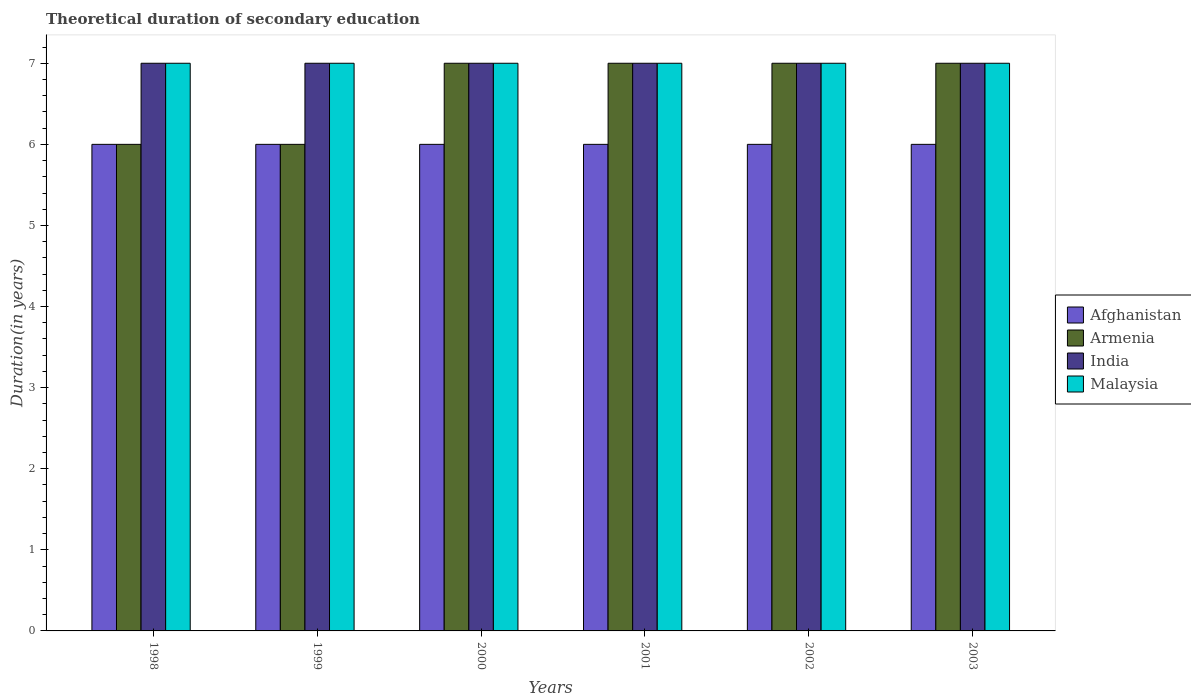How many different coloured bars are there?
Your answer should be compact. 4. How many bars are there on the 3rd tick from the left?
Keep it short and to the point. 4. What is the total theoretical duration of secondary education in Afghanistan in 2000?
Your answer should be very brief. 6. Across all years, what is the maximum total theoretical duration of secondary education in Afghanistan?
Your response must be concise. 6. Across all years, what is the minimum total theoretical duration of secondary education in Afghanistan?
Your response must be concise. 6. In which year was the total theoretical duration of secondary education in Armenia minimum?
Your answer should be compact. 1998. What is the total total theoretical duration of secondary education in Malaysia in the graph?
Ensure brevity in your answer.  42. What is the difference between the total theoretical duration of secondary education in Afghanistan in 2003 and the total theoretical duration of secondary education in Malaysia in 2002?
Your answer should be very brief. -1. What is the average total theoretical duration of secondary education in India per year?
Your response must be concise. 7. In how many years, is the total theoretical duration of secondary education in Afghanistan greater than 5.4 years?
Provide a short and direct response. 6. Is the difference between the total theoretical duration of secondary education in India in 1999 and 2001 greater than the difference between the total theoretical duration of secondary education in Malaysia in 1999 and 2001?
Offer a terse response. No. Is the sum of the total theoretical duration of secondary education in Malaysia in 1999 and 2001 greater than the maximum total theoretical duration of secondary education in Afghanistan across all years?
Give a very brief answer. Yes. What does the 2nd bar from the left in 1999 represents?
Provide a succinct answer. Armenia. What does the 3rd bar from the right in 1998 represents?
Keep it short and to the point. Armenia. Is it the case that in every year, the sum of the total theoretical duration of secondary education in Afghanistan and total theoretical duration of secondary education in Malaysia is greater than the total theoretical duration of secondary education in India?
Provide a short and direct response. Yes. Are all the bars in the graph horizontal?
Your answer should be compact. No. What is the difference between two consecutive major ticks on the Y-axis?
Offer a very short reply. 1. Are the values on the major ticks of Y-axis written in scientific E-notation?
Your answer should be compact. No. Does the graph contain grids?
Offer a very short reply. No. What is the title of the graph?
Your answer should be compact. Theoretical duration of secondary education. What is the label or title of the X-axis?
Make the answer very short. Years. What is the label or title of the Y-axis?
Provide a succinct answer. Duration(in years). What is the Duration(in years) in Afghanistan in 1998?
Offer a very short reply. 6. What is the Duration(in years) of Malaysia in 1998?
Keep it short and to the point. 7. What is the Duration(in years) of Afghanistan in 1999?
Your response must be concise. 6. What is the Duration(in years) of Armenia in 1999?
Give a very brief answer. 6. What is the Duration(in years) in India in 1999?
Provide a succinct answer. 7. What is the Duration(in years) in Afghanistan in 2000?
Keep it short and to the point. 6. What is the Duration(in years) in Armenia in 2000?
Provide a succinct answer. 7. What is the Duration(in years) in Malaysia in 2001?
Offer a terse response. 7. What is the Duration(in years) of Malaysia in 2002?
Ensure brevity in your answer.  7. What is the Duration(in years) of Afghanistan in 2003?
Give a very brief answer. 6. What is the Duration(in years) in India in 2003?
Provide a succinct answer. 7. What is the Duration(in years) of Malaysia in 2003?
Provide a succinct answer. 7. Across all years, what is the maximum Duration(in years) of Armenia?
Your answer should be compact. 7. Across all years, what is the minimum Duration(in years) in Armenia?
Your answer should be compact. 6. Across all years, what is the minimum Duration(in years) in Malaysia?
Ensure brevity in your answer.  7. What is the total Duration(in years) in India in the graph?
Your answer should be compact. 42. What is the difference between the Duration(in years) in Afghanistan in 1998 and that in 1999?
Make the answer very short. 0. What is the difference between the Duration(in years) in Armenia in 1998 and that in 1999?
Your answer should be compact. 0. What is the difference between the Duration(in years) in India in 1998 and that in 1999?
Offer a terse response. 0. What is the difference between the Duration(in years) in Malaysia in 1998 and that in 2000?
Ensure brevity in your answer.  0. What is the difference between the Duration(in years) of India in 1998 and that in 2001?
Your response must be concise. 0. What is the difference between the Duration(in years) of Malaysia in 1998 and that in 2001?
Keep it short and to the point. 0. What is the difference between the Duration(in years) in Afghanistan in 1998 and that in 2002?
Your answer should be very brief. 0. What is the difference between the Duration(in years) of Malaysia in 1998 and that in 2002?
Your response must be concise. 0. What is the difference between the Duration(in years) in Armenia in 1999 and that in 2000?
Provide a short and direct response. -1. What is the difference between the Duration(in years) of Malaysia in 1999 and that in 2000?
Your answer should be very brief. 0. What is the difference between the Duration(in years) in Afghanistan in 1999 and that in 2001?
Your answer should be very brief. 0. What is the difference between the Duration(in years) in Armenia in 1999 and that in 2001?
Make the answer very short. -1. What is the difference between the Duration(in years) of India in 1999 and that in 2002?
Your response must be concise. 0. What is the difference between the Duration(in years) in Afghanistan in 1999 and that in 2003?
Ensure brevity in your answer.  0. What is the difference between the Duration(in years) in India in 1999 and that in 2003?
Your response must be concise. 0. What is the difference between the Duration(in years) of Afghanistan in 2000 and that in 2001?
Your answer should be very brief. 0. What is the difference between the Duration(in years) of Armenia in 2000 and that in 2001?
Keep it short and to the point. 0. What is the difference between the Duration(in years) of Malaysia in 2000 and that in 2001?
Provide a short and direct response. 0. What is the difference between the Duration(in years) of Armenia in 2000 and that in 2003?
Your answer should be compact. 0. What is the difference between the Duration(in years) of India in 2000 and that in 2003?
Offer a terse response. 0. What is the difference between the Duration(in years) of Malaysia in 2000 and that in 2003?
Your answer should be very brief. 0. What is the difference between the Duration(in years) in Afghanistan in 2001 and that in 2002?
Offer a terse response. 0. What is the difference between the Duration(in years) of Armenia in 2001 and that in 2002?
Ensure brevity in your answer.  0. What is the difference between the Duration(in years) of India in 2001 and that in 2002?
Offer a very short reply. 0. What is the difference between the Duration(in years) in India in 2001 and that in 2003?
Make the answer very short. 0. What is the difference between the Duration(in years) in Armenia in 2002 and that in 2003?
Keep it short and to the point. 0. What is the difference between the Duration(in years) in India in 2002 and that in 2003?
Ensure brevity in your answer.  0. What is the difference between the Duration(in years) of Afghanistan in 1998 and the Duration(in years) of Armenia in 1999?
Offer a terse response. 0. What is the difference between the Duration(in years) of Afghanistan in 1998 and the Duration(in years) of Malaysia in 1999?
Ensure brevity in your answer.  -1. What is the difference between the Duration(in years) in India in 1998 and the Duration(in years) in Malaysia in 1999?
Offer a terse response. 0. What is the difference between the Duration(in years) of Afghanistan in 1998 and the Duration(in years) of Armenia in 2000?
Your answer should be compact. -1. What is the difference between the Duration(in years) in Afghanistan in 1998 and the Duration(in years) in India in 2000?
Give a very brief answer. -1. What is the difference between the Duration(in years) of Afghanistan in 1998 and the Duration(in years) of Armenia in 2001?
Your answer should be very brief. -1. What is the difference between the Duration(in years) in Afghanistan in 1998 and the Duration(in years) in Malaysia in 2001?
Your answer should be very brief. -1. What is the difference between the Duration(in years) of Armenia in 1998 and the Duration(in years) of India in 2001?
Offer a terse response. -1. What is the difference between the Duration(in years) in Armenia in 1998 and the Duration(in years) in Malaysia in 2001?
Keep it short and to the point. -1. What is the difference between the Duration(in years) of India in 1998 and the Duration(in years) of Malaysia in 2001?
Provide a short and direct response. 0. What is the difference between the Duration(in years) of Afghanistan in 1998 and the Duration(in years) of Armenia in 2002?
Your answer should be very brief. -1. What is the difference between the Duration(in years) in Afghanistan in 1998 and the Duration(in years) in India in 2002?
Your response must be concise. -1. What is the difference between the Duration(in years) of Afghanistan in 1998 and the Duration(in years) of Malaysia in 2002?
Give a very brief answer. -1. What is the difference between the Duration(in years) of Armenia in 1998 and the Duration(in years) of Malaysia in 2002?
Your response must be concise. -1. What is the difference between the Duration(in years) in Afghanistan in 1998 and the Duration(in years) in Armenia in 2003?
Offer a terse response. -1. What is the difference between the Duration(in years) in Armenia in 1998 and the Duration(in years) in India in 2003?
Your answer should be very brief. -1. What is the difference between the Duration(in years) of Afghanistan in 1999 and the Duration(in years) of Armenia in 2000?
Ensure brevity in your answer.  -1. What is the difference between the Duration(in years) in Afghanistan in 1999 and the Duration(in years) in Malaysia in 2000?
Provide a succinct answer. -1. What is the difference between the Duration(in years) of Afghanistan in 1999 and the Duration(in years) of India in 2001?
Make the answer very short. -1. What is the difference between the Duration(in years) in Afghanistan in 1999 and the Duration(in years) in Malaysia in 2001?
Your answer should be very brief. -1. What is the difference between the Duration(in years) of Armenia in 1999 and the Duration(in years) of Malaysia in 2001?
Provide a succinct answer. -1. What is the difference between the Duration(in years) of Afghanistan in 1999 and the Duration(in years) of Armenia in 2002?
Your answer should be compact. -1. What is the difference between the Duration(in years) in India in 1999 and the Duration(in years) in Malaysia in 2002?
Provide a succinct answer. 0. What is the difference between the Duration(in years) of Armenia in 1999 and the Duration(in years) of India in 2003?
Make the answer very short. -1. What is the difference between the Duration(in years) in Afghanistan in 2000 and the Duration(in years) in Armenia in 2001?
Your response must be concise. -1. What is the difference between the Duration(in years) of Afghanistan in 2000 and the Duration(in years) of India in 2001?
Provide a short and direct response. -1. What is the difference between the Duration(in years) of Armenia in 2000 and the Duration(in years) of Malaysia in 2001?
Provide a short and direct response. 0. What is the difference between the Duration(in years) of Afghanistan in 2000 and the Duration(in years) of Armenia in 2002?
Ensure brevity in your answer.  -1. What is the difference between the Duration(in years) of Afghanistan in 2000 and the Duration(in years) of India in 2002?
Give a very brief answer. -1. What is the difference between the Duration(in years) in Afghanistan in 2000 and the Duration(in years) in Malaysia in 2002?
Offer a terse response. -1. What is the difference between the Duration(in years) in Armenia in 2000 and the Duration(in years) in India in 2002?
Your response must be concise. 0. What is the difference between the Duration(in years) in Armenia in 2000 and the Duration(in years) in Malaysia in 2002?
Your response must be concise. 0. What is the difference between the Duration(in years) of Afghanistan in 2000 and the Duration(in years) of Armenia in 2003?
Your answer should be very brief. -1. What is the difference between the Duration(in years) in Afghanistan in 2000 and the Duration(in years) in India in 2003?
Your answer should be compact. -1. What is the difference between the Duration(in years) of India in 2000 and the Duration(in years) of Malaysia in 2003?
Make the answer very short. 0. What is the difference between the Duration(in years) in Afghanistan in 2001 and the Duration(in years) in Armenia in 2002?
Ensure brevity in your answer.  -1. What is the difference between the Duration(in years) of Afghanistan in 2001 and the Duration(in years) of India in 2002?
Give a very brief answer. -1. What is the difference between the Duration(in years) of Afghanistan in 2001 and the Duration(in years) of Malaysia in 2002?
Your answer should be very brief. -1. What is the difference between the Duration(in years) of Armenia in 2001 and the Duration(in years) of Malaysia in 2002?
Provide a short and direct response. 0. What is the difference between the Duration(in years) in India in 2001 and the Duration(in years) in Malaysia in 2002?
Your answer should be compact. 0. What is the difference between the Duration(in years) in Afghanistan in 2001 and the Duration(in years) in India in 2003?
Your answer should be very brief. -1. What is the difference between the Duration(in years) in Afghanistan in 2001 and the Duration(in years) in Malaysia in 2003?
Your answer should be compact. -1. What is the difference between the Duration(in years) in Armenia in 2001 and the Duration(in years) in India in 2003?
Your response must be concise. 0. What is the difference between the Duration(in years) in Armenia in 2001 and the Duration(in years) in Malaysia in 2003?
Give a very brief answer. 0. What is the difference between the Duration(in years) in Armenia in 2002 and the Duration(in years) in Malaysia in 2003?
Make the answer very short. 0. What is the difference between the Duration(in years) of India in 2002 and the Duration(in years) of Malaysia in 2003?
Keep it short and to the point. 0. What is the average Duration(in years) in Afghanistan per year?
Keep it short and to the point. 6. What is the average Duration(in years) in Armenia per year?
Your answer should be compact. 6.67. What is the average Duration(in years) of India per year?
Offer a very short reply. 7. What is the average Duration(in years) of Malaysia per year?
Offer a terse response. 7. In the year 1998, what is the difference between the Duration(in years) in Afghanistan and Duration(in years) in Armenia?
Offer a terse response. 0. In the year 1998, what is the difference between the Duration(in years) of Afghanistan and Duration(in years) of India?
Your answer should be compact. -1. In the year 1998, what is the difference between the Duration(in years) of Armenia and Duration(in years) of India?
Give a very brief answer. -1. In the year 1998, what is the difference between the Duration(in years) of India and Duration(in years) of Malaysia?
Keep it short and to the point. 0. In the year 1999, what is the difference between the Duration(in years) of Afghanistan and Duration(in years) of India?
Offer a very short reply. -1. In the year 1999, what is the difference between the Duration(in years) in Armenia and Duration(in years) in India?
Give a very brief answer. -1. In the year 1999, what is the difference between the Duration(in years) of Armenia and Duration(in years) of Malaysia?
Keep it short and to the point. -1. In the year 2000, what is the difference between the Duration(in years) of Afghanistan and Duration(in years) of Malaysia?
Make the answer very short. -1. In the year 2000, what is the difference between the Duration(in years) of Armenia and Duration(in years) of Malaysia?
Provide a succinct answer. 0. In the year 2000, what is the difference between the Duration(in years) of India and Duration(in years) of Malaysia?
Give a very brief answer. 0. In the year 2001, what is the difference between the Duration(in years) of Afghanistan and Duration(in years) of India?
Your answer should be very brief. -1. In the year 2001, what is the difference between the Duration(in years) in Afghanistan and Duration(in years) in Malaysia?
Provide a succinct answer. -1. In the year 2001, what is the difference between the Duration(in years) in Armenia and Duration(in years) in Malaysia?
Your answer should be compact. 0. In the year 2002, what is the difference between the Duration(in years) of Afghanistan and Duration(in years) of Armenia?
Ensure brevity in your answer.  -1. In the year 2002, what is the difference between the Duration(in years) in Armenia and Duration(in years) in Malaysia?
Give a very brief answer. 0. In the year 2003, what is the difference between the Duration(in years) of Afghanistan and Duration(in years) of Armenia?
Give a very brief answer. -1. In the year 2003, what is the difference between the Duration(in years) in Afghanistan and Duration(in years) in India?
Keep it short and to the point. -1. In the year 2003, what is the difference between the Duration(in years) in Armenia and Duration(in years) in Malaysia?
Keep it short and to the point. 0. In the year 2003, what is the difference between the Duration(in years) of India and Duration(in years) of Malaysia?
Your response must be concise. 0. What is the ratio of the Duration(in years) in Armenia in 1998 to that in 1999?
Your answer should be compact. 1. What is the ratio of the Duration(in years) of India in 1998 to that in 1999?
Make the answer very short. 1. What is the ratio of the Duration(in years) of Afghanistan in 1998 to that in 2000?
Your answer should be compact. 1. What is the ratio of the Duration(in years) of Armenia in 1998 to that in 2000?
Offer a terse response. 0.86. What is the ratio of the Duration(in years) of India in 1998 to that in 2000?
Make the answer very short. 1. What is the ratio of the Duration(in years) in Malaysia in 1998 to that in 2000?
Offer a terse response. 1. What is the ratio of the Duration(in years) of Afghanistan in 1998 to that in 2001?
Your response must be concise. 1. What is the ratio of the Duration(in years) in India in 1998 to that in 2001?
Make the answer very short. 1. What is the ratio of the Duration(in years) of Malaysia in 1998 to that in 2001?
Offer a terse response. 1. What is the ratio of the Duration(in years) of Afghanistan in 1998 to that in 2002?
Give a very brief answer. 1. What is the ratio of the Duration(in years) in Armenia in 1998 to that in 2002?
Provide a short and direct response. 0.86. What is the ratio of the Duration(in years) in India in 1998 to that in 2002?
Provide a short and direct response. 1. What is the ratio of the Duration(in years) in Malaysia in 1998 to that in 2002?
Make the answer very short. 1. What is the ratio of the Duration(in years) of Afghanistan in 1998 to that in 2003?
Your answer should be very brief. 1. What is the ratio of the Duration(in years) of Armenia in 1998 to that in 2003?
Ensure brevity in your answer.  0.86. What is the ratio of the Duration(in years) in India in 1998 to that in 2003?
Your answer should be compact. 1. What is the ratio of the Duration(in years) of Malaysia in 1999 to that in 2001?
Provide a short and direct response. 1. What is the ratio of the Duration(in years) in Afghanistan in 1999 to that in 2002?
Give a very brief answer. 1. What is the ratio of the Duration(in years) in Armenia in 1999 to that in 2002?
Your answer should be compact. 0.86. What is the ratio of the Duration(in years) of India in 1999 to that in 2002?
Give a very brief answer. 1. What is the ratio of the Duration(in years) in Malaysia in 1999 to that in 2002?
Make the answer very short. 1. What is the ratio of the Duration(in years) of Afghanistan in 1999 to that in 2003?
Your response must be concise. 1. What is the ratio of the Duration(in years) of India in 1999 to that in 2003?
Keep it short and to the point. 1. What is the ratio of the Duration(in years) in Malaysia in 2000 to that in 2001?
Provide a short and direct response. 1. What is the ratio of the Duration(in years) in Afghanistan in 2000 to that in 2002?
Your response must be concise. 1. What is the ratio of the Duration(in years) of Armenia in 2000 to that in 2002?
Your response must be concise. 1. What is the ratio of the Duration(in years) of Afghanistan in 2000 to that in 2003?
Provide a short and direct response. 1. What is the ratio of the Duration(in years) of Armenia in 2000 to that in 2003?
Your answer should be compact. 1. What is the ratio of the Duration(in years) in Afghanistan in 2001 to that in 2002?
Your answer should be compact. 1. What is the ratio of the Duration(in years) in Armenia in 2001 to that in 2002?
Make the answer very short. 1. What is the ratio of the Duration(in years) of India in 2001 to that in 2002?
Your answer should be very brief. 1. What is the ratio of the Duration(in years) of Afghanistan in 2001 to that in 2003?
Your answer should be very brief. 1. What is the ratio of the Duration(in years) in Armenia in 2001 to that in 2003?
Offer a terse response. 1. What is the ratio of the Duration(in years) in Malaysia in 2001 to that in 2003?
Ensure brevity in your answer.  1. What is the ratio of the Duration(in years) in Armenia in 2002 to that in 2003?
Give a very brief answer. 1. What is the ratio of the Duration(in years) of India in 2002 to that in 2003?
Keep it short and to the point. 1. What is the ratio of the Duration(in years) of Malaysia in 2002 to that in 2003?
Offer a very short reply. 1. What is the difference between the highest and the second highest Duration(in years) of Armenia?
Provide a succinct answer. 0. What is the difference between the highest and the second highest Duration(in years) of Malaysia?
Offer a terse response. 0. What is the difference between the highest and the lowest Duration(in years) of Malaysia?
Offer a very short reply. 0. 